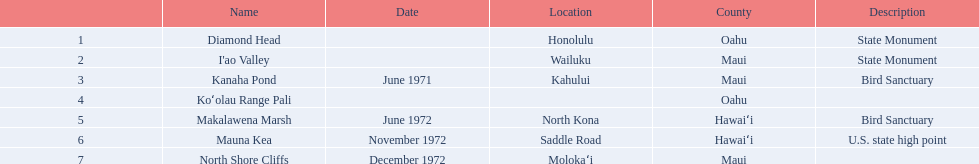How many locations are bird sanctuaries. 2. 